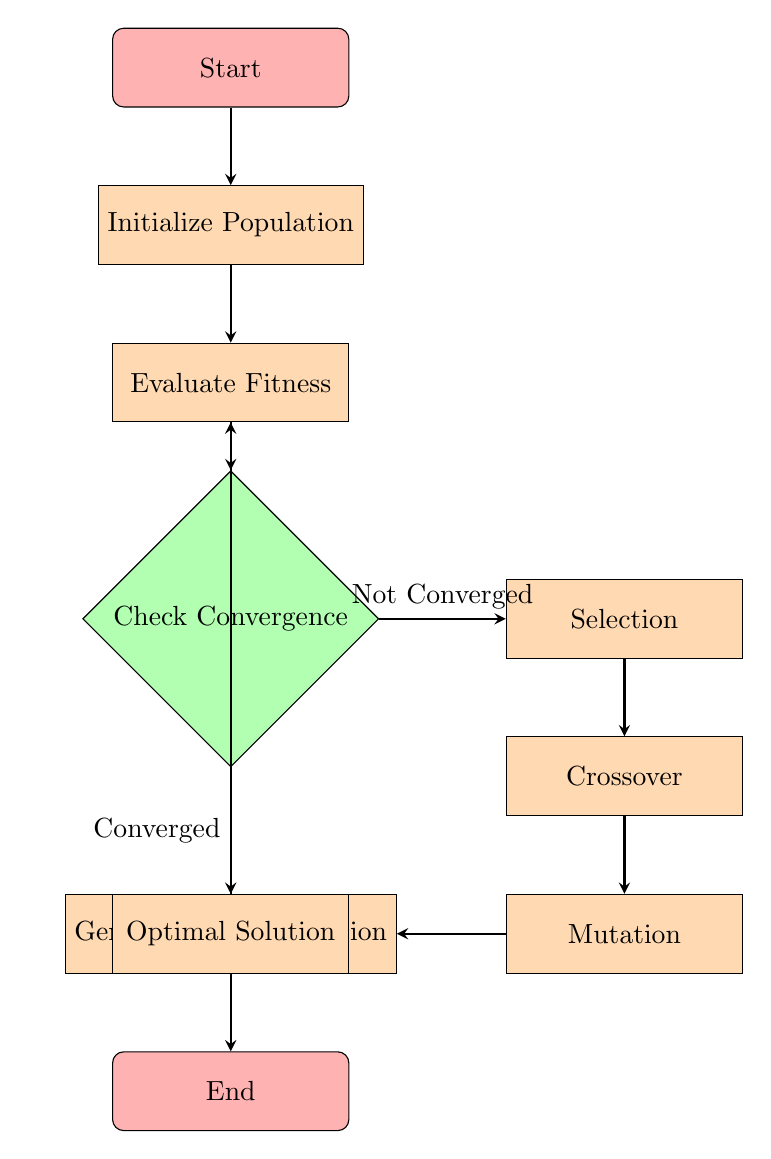What is the starting point of the diagram? The diagram begins at the "Start" node, which is indicated at the top of the flowchart.
Answer: Start What follows after "Evaluate Fitness"? The next step after "Evaluate Fitness" is the "Check Convergence" decision node.
Answer: Check Convergence How many processes are involved in the evolution process? There are five processes specified in the diagram: Initialize Population, Evaluate Fitness, Selection, Crossover, and Mutation.
Answer: Five What happens if the convergence check indicates 'Not Converged'? If the convergence check indicates 'Not Converged', the process transitions to the "Selection" node.
Answer: Selection What is the outcome if the convergence check indicates 'Converged'? If the convergence check indicates 'Converged', the process leads directly to the "Optimal Solution" node.
Answer: Optimal Solution Which node generates a new population? The "Generate New Population" node is responsible for generating a new population in the flowchart.
Answer: Generate New Population Which process occurs after "Crossover"? The process that occurs after "Crossover" is "Mutation".
Answer: Mutation What precedes the "Optimal Solution" node? The "Check Convergence" node precedes the "Optimal Solution" node.
Answer: Check Convergence What is the final node in the diagram? The final node in the diagram is the "End" node, positioned at the bottom.
Answer: End 